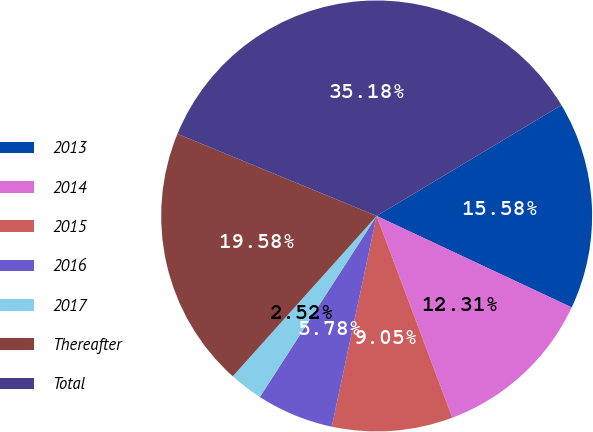Convert chart to OTSL. <chart><loc_0><loc_0><loc_500><loc_500><pie_chart><fcel>2013<fcel>2014<fcel>2015<fcel>2016<fcel>2017<fcel>Thereafter<fcel>Total<nl><fcel>15.58%<fcel>12.31%<fcel>9.05%<fcel>5.78%<fcel>2.52%<fcel>19.58%<fcel>35.18%<nl></chart> 